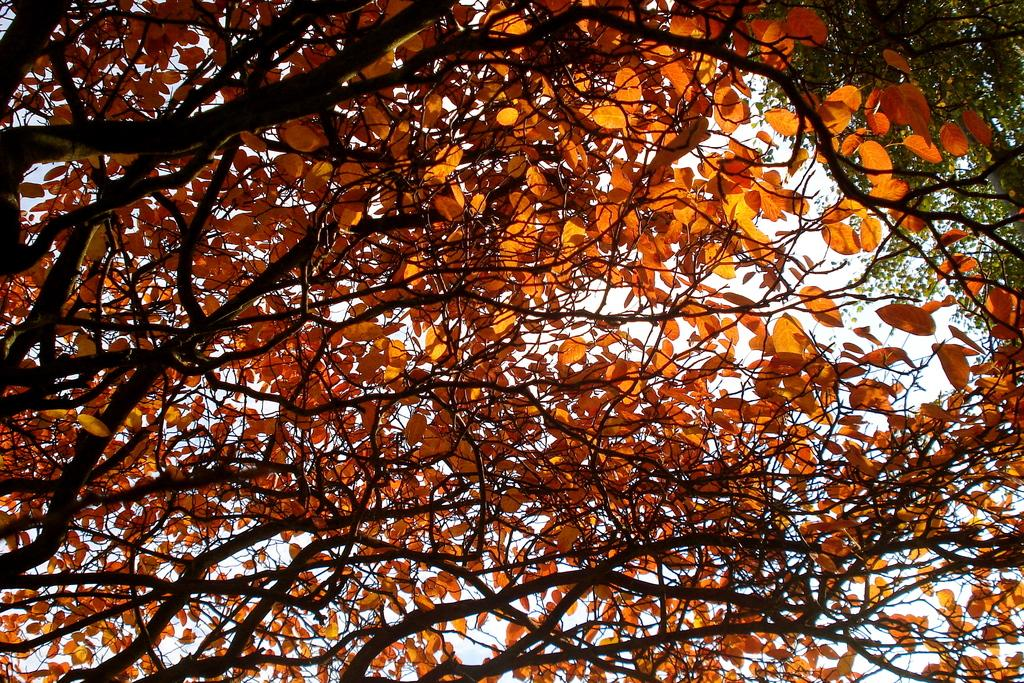What type of vegetation can be seen in the image? There are trees in the image. What colors are the leaves of the trees? The trees have green and orange color leaves. What is visible in the background of the image? The sky is visible in the background of the image. How many plastic women are present in the image? There are no plastic women present in the image; it features trees with green and orange leaves and a visible sky in the background. 